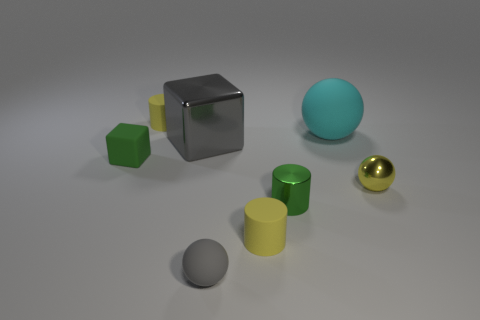Is the number of tiny gray matte spheres less than the number of gray things?
Ensure brevity in your answer.  Yes. Is the material of the small green cylinder the same as the cylinder behind the large gray metallic thing?
Your answer should be compact. No. The small metallic object on the left side of the large ball has what shape?
Provide a succinct answer. Cylinder. Is there anything else of the same color as the large ball?
Offer a very short reply. No. Are there fewer big gray shiny objects right of the big rubber thing than cyan spheres?
Keep it short and to the point. Yes. How many metal cylinders have the same size as the yellow shiny thing?
Provide a succinct answer. 1. What shape is the rubber object that is the same color as the shiny cylinder?
Offer a very short reply. Cube. What is the shape of the gray object that is behind the yellow cylinder right of the small yellow rubber cylinder that is behind the cyan matte thing?
Provide a succinct answer. Cube. There is a small sphere that is right of the tiny gray thing; what color is it?
Keep it short and to the point. Yellow. What number of objects are either tiny cylinders that are to the right of the gray cube or tiny yellow matte things that are in front of the small green cylinder?
Make the answer very short. 2. 